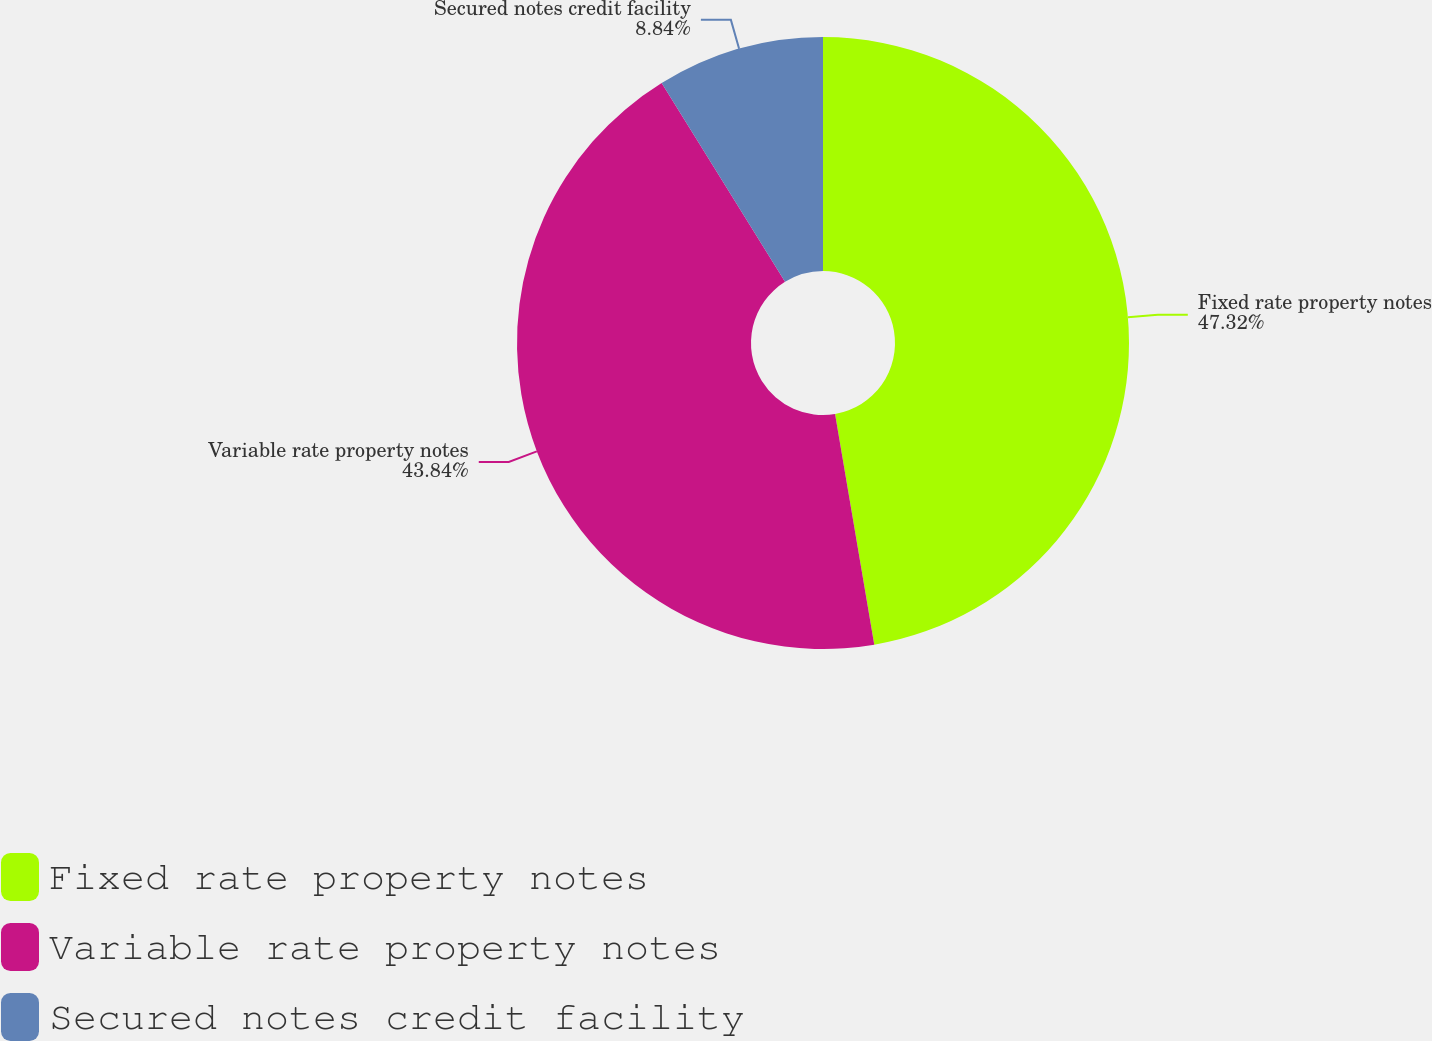Convert chart. <chart><loc_0><loc_0><loc_500><loc_500><pie_chart><fcel>Fixed rate property notes<fcel>Variable rate property notes<fcel>Secured notes credit facility<nl><fcel>47.32%<fcel>43.84%<fcel>8.84%<nl></chart> 